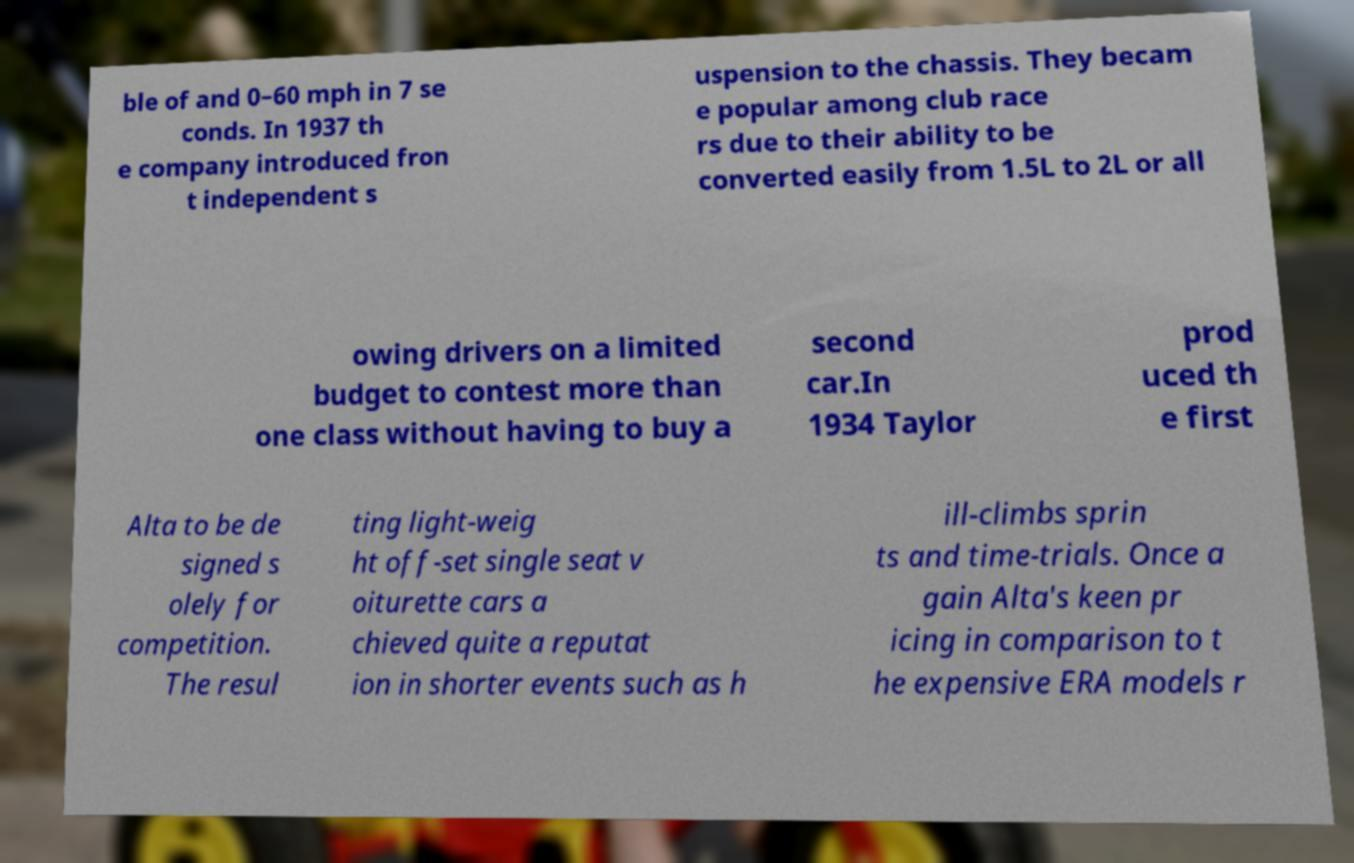Please identify and transcribe the text found in this image. ble of and 0–60 mph in 7 se conds. In 1937 th e company introduced fron t independent s uspension to the chassis. They becam e popular among club race rs due to their ability to be converted easily from 1.5L to 2L or all owing drivers on a limited budget to contest more than one class without having to buy a second car.In 1934 Taylor prod uced th e first Alta to be de signed s olely for competition. The resul ting light-weig ht off-set single seat v oiturette cars a chieved quite a reputat ion in shorter events such as h ill-climbs sprin ts and time-trials. Once a gain Alta's keen pr icing in comparison to t he expensive ERA models r 